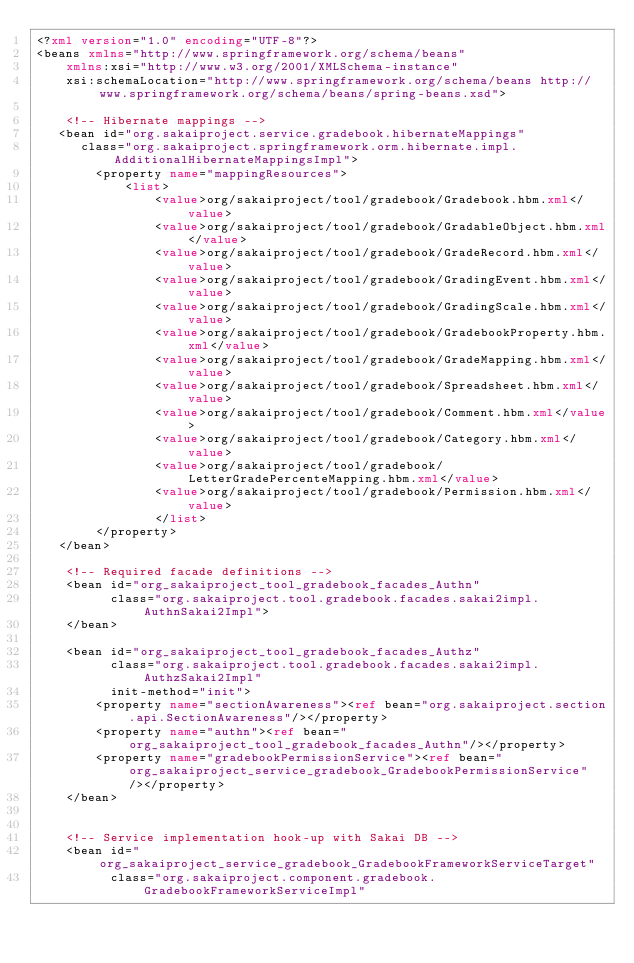<code> <loc_0><loc_0><loc_500><loc_500><_XML_><?xml version="1.0" encoding="UTF-8"?>
<beans xmlns="http://www.springframework.org/schema/beans"
    xmlns:xsi="http://www.w3.org/2001/XMLSchema-instance"
    xsi:schemaLocation="http://www.springframework.org/schema/beans http://www.springframework.org/schema/beans/spring-beans.xsd">

	<!-- Hibernate mappings -->
   <bean id="org.sakaiproject.service.gradebook.hibernateMappings"
      class="org.sakaiproject.springframework.orm.hibernate.impl.AdditionalHibernateMappingsImpl">
		<property name="mappingResources">
		    <list>
  				<value>org/sakaiproject/tool/gradebook/Gradebook.hbm.xml</value>
	  			<value>org/sakaiproject/tool/gradebook/GradableObject.hbm.xml</value>
		  		<value>org/sakaiproject/tool/gradebook/GradeRecord.hbm.xml</value>
			  	<value>org/sakaiproject/tool/gradebook/GradingEvent.hbm.xml</value>
				<value>org/sakaiproject/tool/gradebook/GradingScale.hbm.xml</value>
  				<value>org/sakaiproject/tool/gradebook/GradebookProperty.hbm.xml</value>
	  			<value>org/sakaiproject/tool/gradebook/GradeMapping.hbm.xml</value>
          		<value>org/sakaiproject/tool/gradebook/Spreadsheet.hbm.xml</value>
          		<value>org/sakaiproject/tool/gradebook/Comment.hbm.xml</value>
          		<value>org/sakaiproject/tool/gradebook/Category.hbm.xml</value>
          		<value>org/sakaiproject/tool/gradebook/LetterGradePercenteMapping.hbm.xml</value>
          		<value>org/sakaiproject/tool/gradebook/Permission.hbm.xml</value>
        		</list>
		</property>
   </bean>

	<!-- Required facade definitions -->
    <bean id="org_sakaiproject_tool_gradebook_facades_Authn"
          class="org.sakaiproject.tool.gradebook.facades.sakai2impl.AuthnSakai2Impl">
    </bean>

    <bean id="org_sakaiproject_tool_gradebook_facades_Authz"
          class="org.sakaiproject.tool.gradebook.facades.sakai2impl.AuthzSakai2Impl"
          init-method="init">
        <property name="sectionAwareness"><ref bean="org.sakaiproject.section.api.SectionAwareness"/></property>
        <property name="authn"><ref bean="org_sakaiproject_tool_gradebook_facades_Authn"/></property>
        <property name="gradebookPermissionService"><ref bean="org_sakaiproject_service_gradebook_GradebookPermissionService"/></property>
    </bean>


    <!-- Service implementation hook-up with Sakai DB -->
    <bean id="org_sakaiproject_service_gradebook_GradebookFrameworkServiceTarget"
          class="org.sakaiproject.component.gradebook.GradebookFrameworkServiceImpl"</code> 